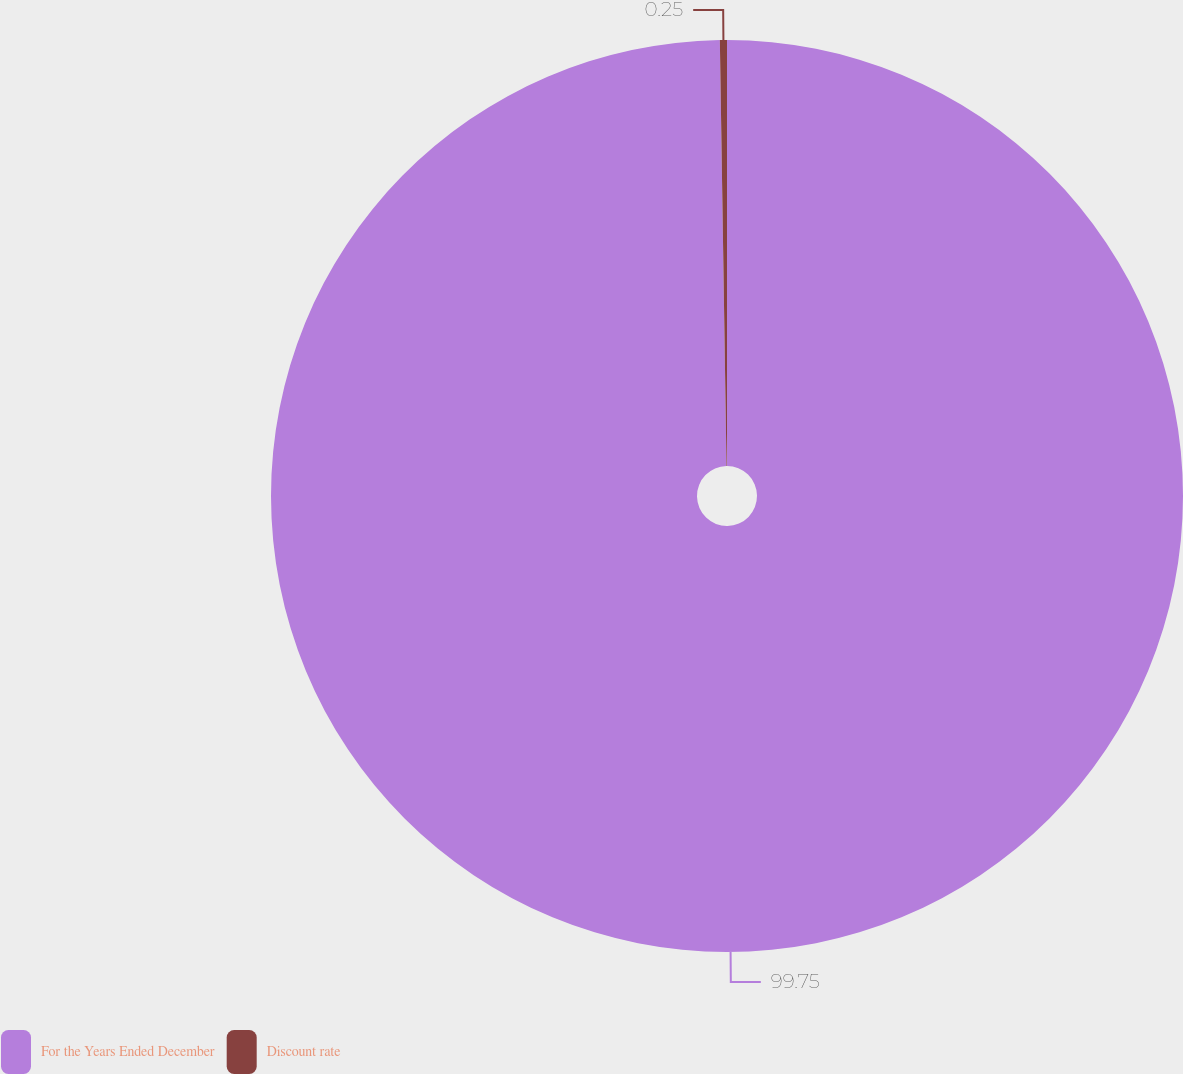<chart> <loc_0><loc_0><loc_500><loc_500><pie_chart><fcel>For the Years Ended December<fcel>Discount rate<nl><fcel>99.75%<fcel>0.25%<nl></chart> 